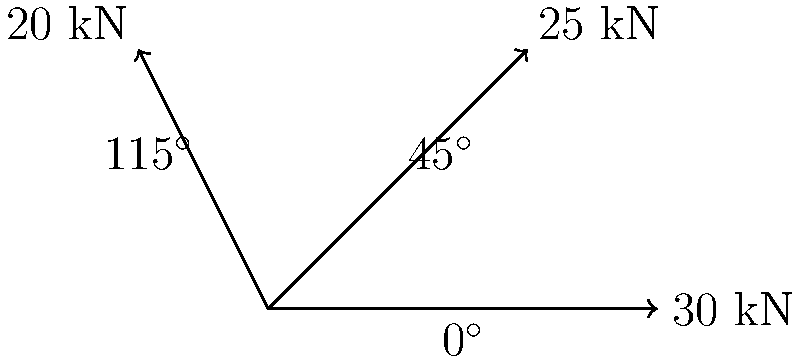During the annual tractor pull competition at the Morrison Harvest Festival, three tractors are pulling a heavy load simultaneously in different directions. Tractor A exerts a force of 30 kN at 0°, tractor B exerts 25 kN at 45°, and tractor C exerts 20 kN at 115°. Calculate the magnitude of the resultant force vector to the nearest whole number. To find the resultant force vector, we need to add the three force vectors using the component method:

1. Break down each force into x and y components:
   Tractor A: $F_{Ax} = 30 \cos(0°) = 30$ kN, $F_{Ay} = 30 \sin(0°) = 0$ kN
   Tractor B: $F_{Bx} = 25 \cos(45°) \approx 17.68$ kN, $F_{By} = 25 \sin(45°) \approx 17.68$ kN
   Tractor C: $F_{Cx} = 20 \cos(115°) \approx -8.45$ kN, $F_{Cy} = 20 \sin(115°) \approx 18.19$ kN

2. Sum the x and y components:
   $F_x = F_{Ax} + F_{Bx} + F_{Cx} = 30 + 17.68 - 8.45 = 39.23$ kN
   $F_y = F_{Ay} + F_{By} + F_{Cy} = 0 + 17.68 + 18.19 = 35.87$ kN

3. Calculate the magnitude of the resultant force using the Pythagorean theorem:
   $F_R = \sqrt{F_x^2 + F_y^2} = \sqrt{39.23^2 + 35.87^2} \approx 53.16$ kN

4. Round to the nearest whole number: 53 kN
Answer: 53 kN 